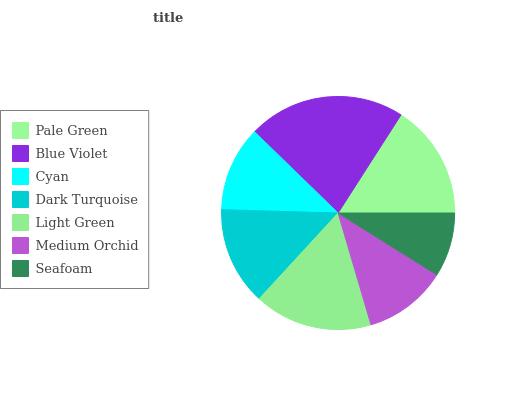Is Seafoam the minimum?
Answer yes or no. Yes. Is Blue Violet the maximum?
Answer yes or no. Yes. Is Cyan the minimum?
Answer yes or no. No. Is Cyan the maximum?
Answer yes or no. No. Is Blue Violet greater than Cyan?
Answer yes or no. Yes. Is Cyan less than Blue Violet?
Answer yes or no. Yes. Is Cyan greater than Blue Violet?
Answer yes or no. No. Is Blue Violet less than Cyan?
Answer yes or no. No. Is Dark Turquoise the high median?
Answer yes or no. Yes. Is Dark Turquoise the low median?
Answer yes or no. Yes. Is Blue Violet the high median?
Answer yes or no. No. Is Medium Orchid the low median?
Answer yes or no. No. 